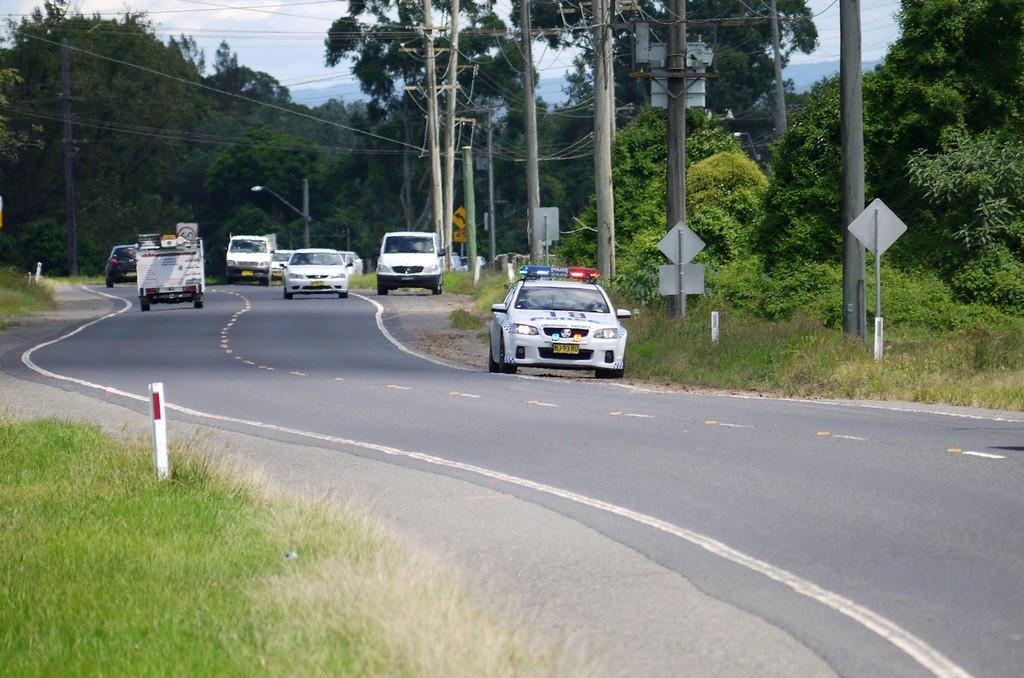How would you summarize this image in a sentence or two? This image is clicked on the road. There are vehicles moving on the road. Beside the road there are poles and sign boards. In the bottom left there's grass on the ground. In the background there are trees. At the top there is the sky. 